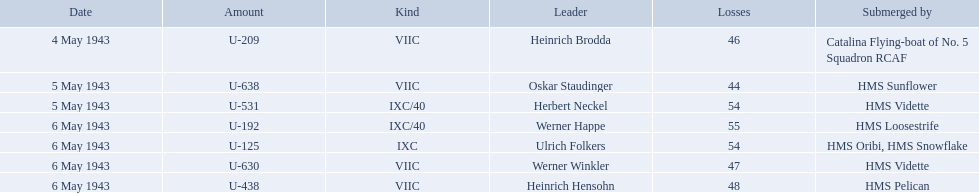Who were the captains in the ons 5 convoy? Heinrich Brodda, Oskar Staudinger, Herbert Neckel, Werner Happe, Ulrich Folkers, Werner Winkler, Heinrich Hensohn. Which ones lost their u-boat on may 5? Oskar Staudinger, Herbert Neckel. Of those, which one is not oskar staudinger? Herbert Neckel. Who are the captains of the u boats? Heinrich Brodda, Oskar Staudinger, Herbert Neckel, Werner Happe, Ulrich Folkers, Werner Winkler, Heinrich Hensohn. What are the dates the u boat captains were lost? 4 May 1943, 5 May 1943, 5 May 1943, 6 May 1943, 6 May 1943, 6 May 1943, 6 May 1943. Of these, which were lost on may 5? Oskar Staudinger, Herbert Neckel. Other than oskar staudinger, who else was lost on this day? Herbert Neckel. 